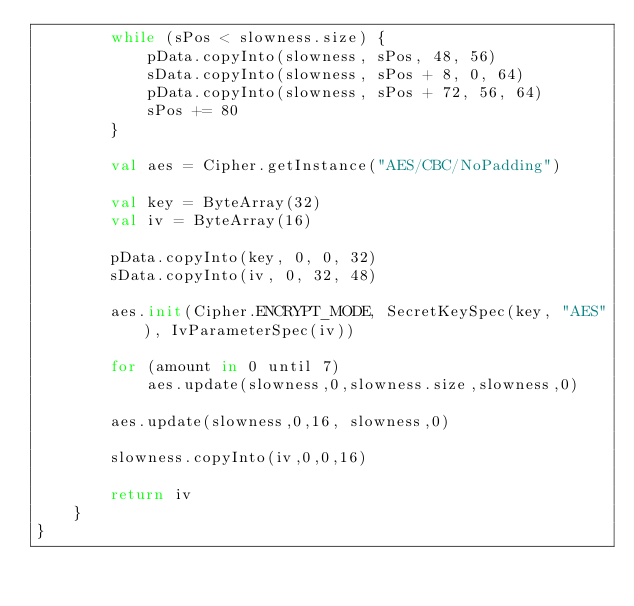Convert code to text. <code><loc_0><loc_0><loc_500><loc_500><_Kotlin_>        while (sPos < slowness.size) {
            pData.copyInto(slowness, sPos, 48, 56)
            sData.copyInto(slowness, sPos + 8, 0, 64)
            pData.copyInto(slowness, sPos + 72, 56, 64)
            sPos += 80
        }

        val aes = Cipher.getInstance("AES/CBC/NoPadding")

        val key = ByteArray(32)
        val iv = ByteArray(16)

        pData.copyInto(key, 0, 0, 32)
        sData.copyInto(iv, 0, 32, 48)

        aes.init(Cipher.ENCRYPT_MODE, SecretKeySpec(key, "AES"), IvParameterSpec(iv))

        for (amount in 0 until 7)
            aes.update(slowness,0,slowness.size,slowness,0)

        aes.update(slowness,0,16, slowness,0)

        slowness.copyInto(iv,0,0,16)

        return iv
    }
}
</code> 